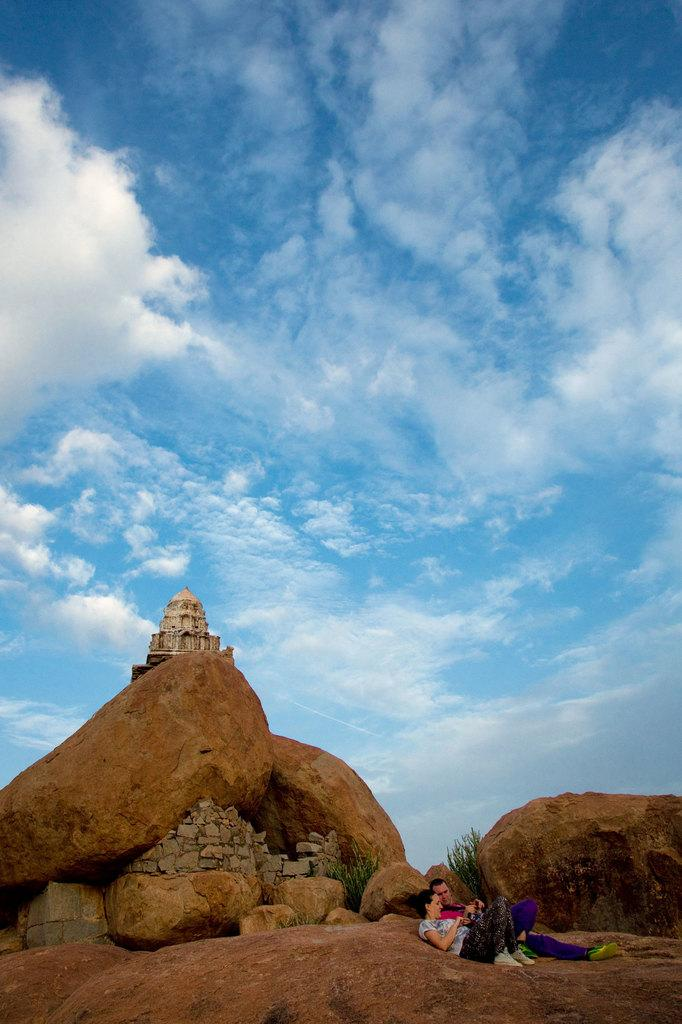How many people are present in the image? There are two people in the image. What type of natural elements can be seen in the image? There are rocks and plants visible in the image. What type of man-made structure is present in the image? There is a building in the image. What can be seen in the background of the image? The sky with clouds is visible in the background of the image. What type of song is being sung by the plants in the image? There are no plants singing in the image; they are stationary plants. What educational institution is the building in the image associated with? The provided facts do not mention any specific educational institution associated with the building in the image. 